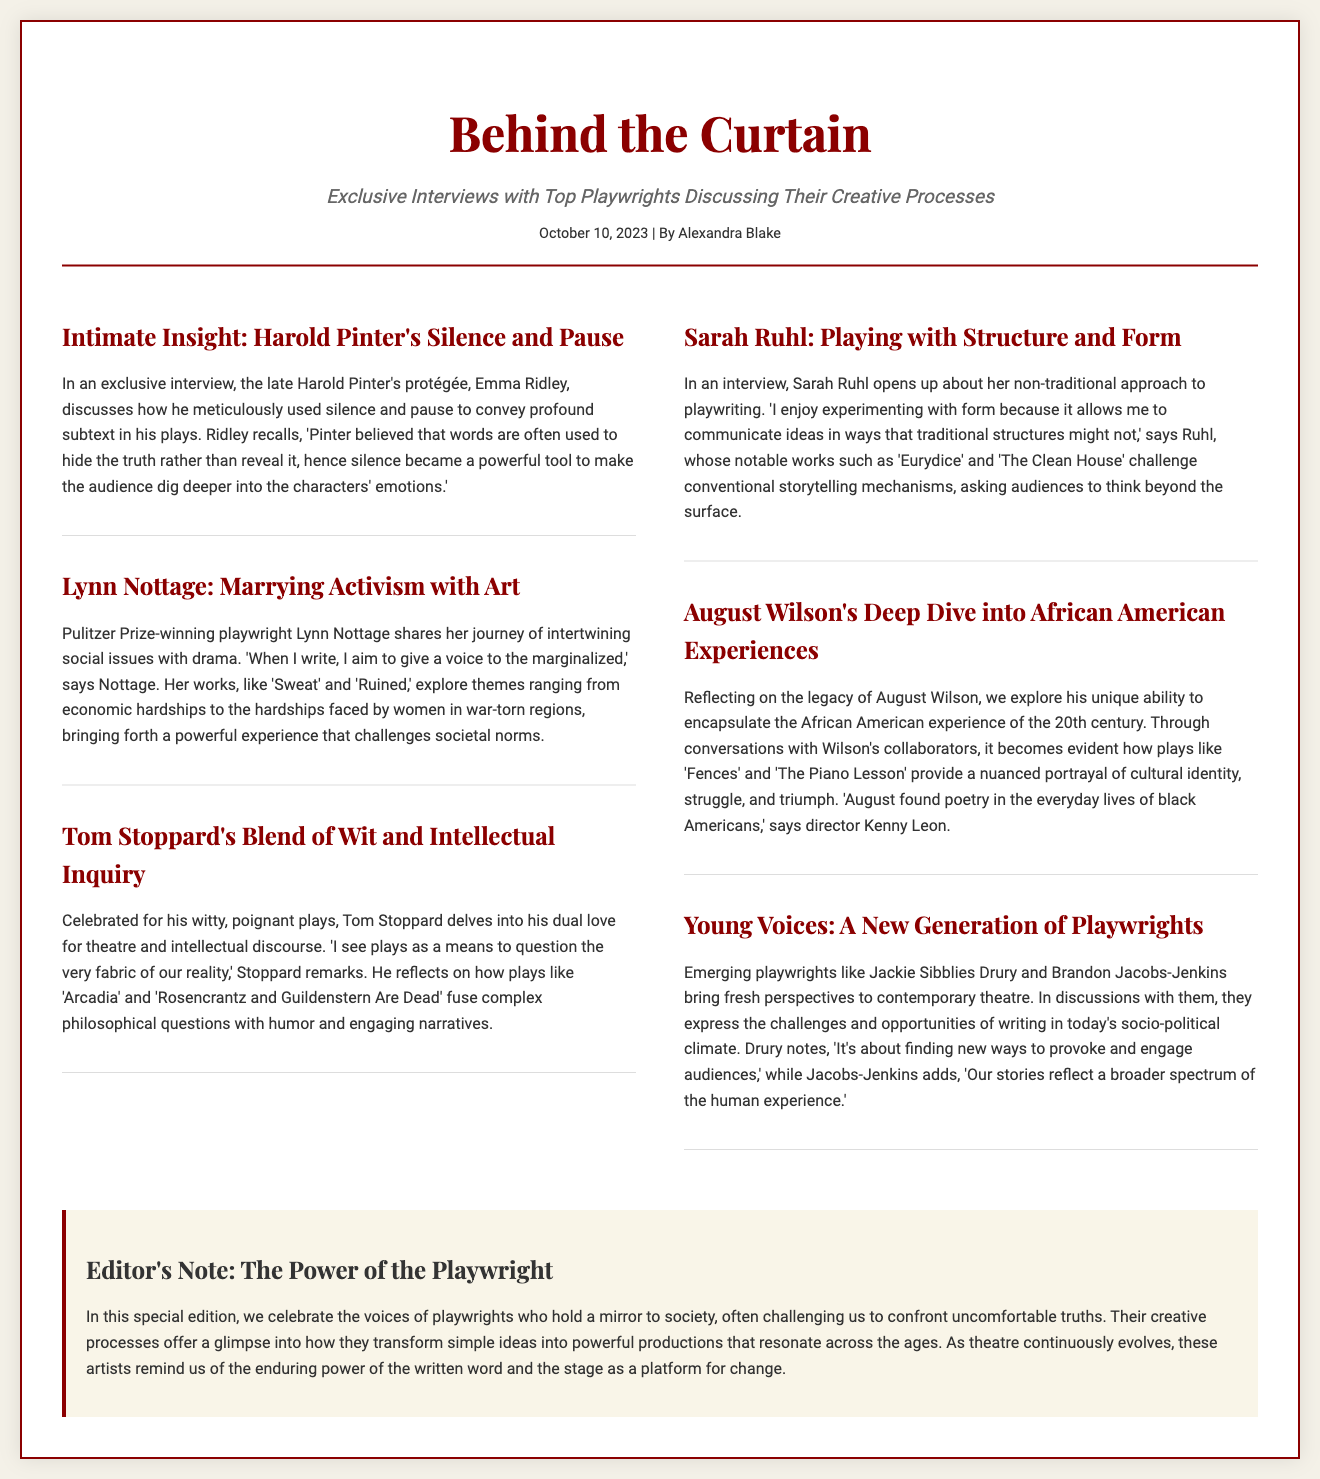what is the title of the article? The title of the article is found in the header section of the document.
Answer: Behind the Curtain who is the author of the article? The author is listed in the meta section under the header of the document.
Answer: Alexandra Blake when was the article published? The date of publication is also found in the meta section of the document.
Answer: October 10, 2023 who discusses Harold Pinter's creative process? The details regarding who discusses Pinter's process is found in the first article.
Answer: Emma Ridley what are the names of two plays by Lynn Nottage mentioned in the article? The article contains specific references to two of Lynn Nottage's works.
Answer: Sweat and Ruined what theme does Tom Stoppard explore in his plays? The article specifically notes the theme Stoppard focuses on in his narrative style.
Answer: Intellectual inquiry which playwright is noted for experimenting with non-traditional structures? The article highlights a playwright known for this approach.
Answer: Sarah Ruhl what does the editorial note primarily celebrate? The editorial section summarizes the main focus of the content shared.
Answer: The voices of playwrights how does the article categorize emerging playwrights? The article provides a specific term to describe this group of theatre writers.
Answer: Young Voices 